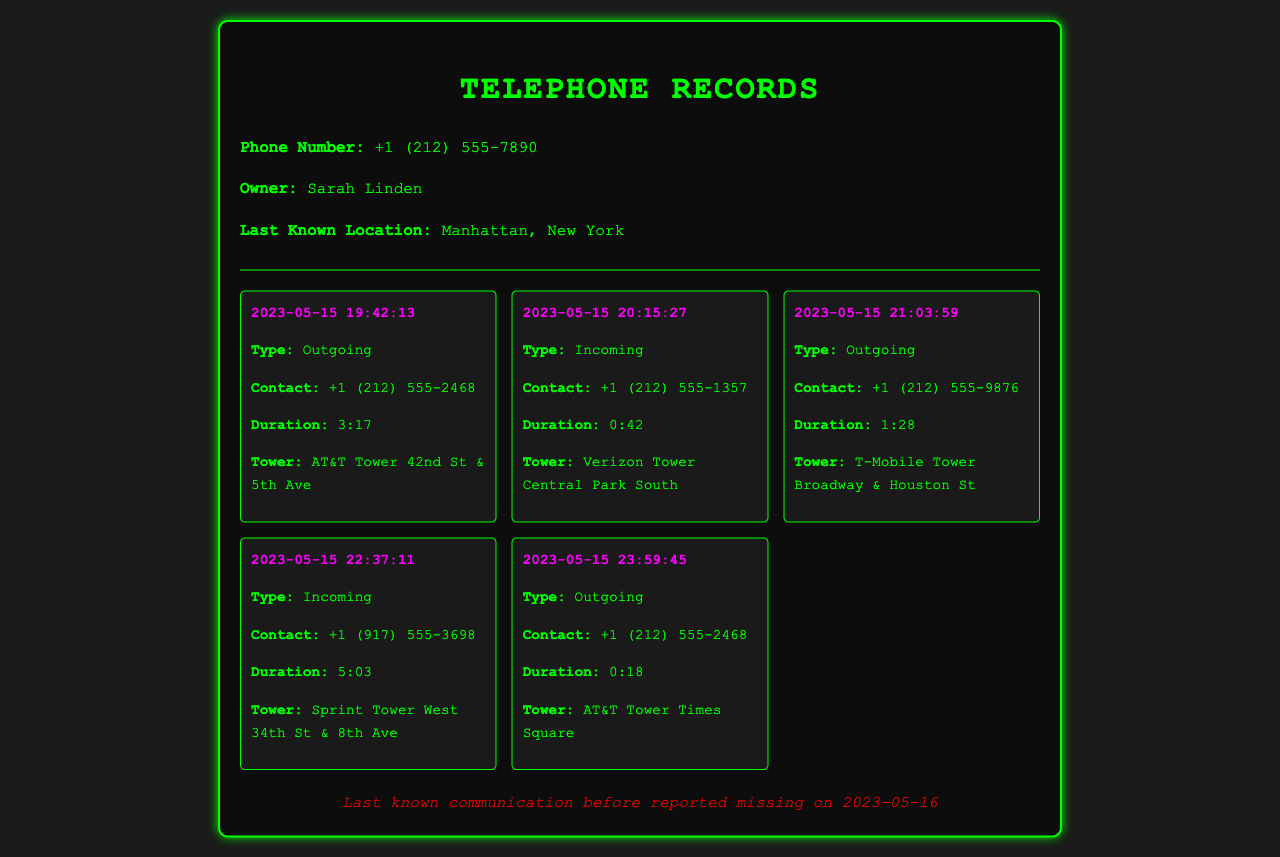What is Sarah Linden's phone number? The phone number is provided at the top of the document in the information section.
Answer: +1 (212) 555-7890 When did Sarah Linden last communicate before being reported missing? The last known communication date is mentioned in the additional information section.
Answer: 2023-05-15 What type of communication was made at 19:42:13? This refers to the timestamp of the first record in the communication log, indicating whether it was incoming or outgoing.
Answer: Outgoing What was the duration of the call from +1 (212) 555-1357? The call duration can be determined from the second record of the list.
Answer: 0:42 Which service tower was used for the call at 22:37:11? This is found in the call details, indicating the tower location for that specific communication.
Answer: Sprint Tower West 34th St & 8th Ave How many total outgoing calls are listed? By reviewing the type of communication in the records, the total number of outgoing calls can be counted.
Answer: 3 Who received the call at 21:03:59? This information can be retrieved from the contact details in the corresponding record.
Answer: +1 (212) 555-9876 What was the exact time of the last outgoing call? The last record in the communications log provides the timestamp of the last call.
Answer: 2023-05-15 23:59:45 